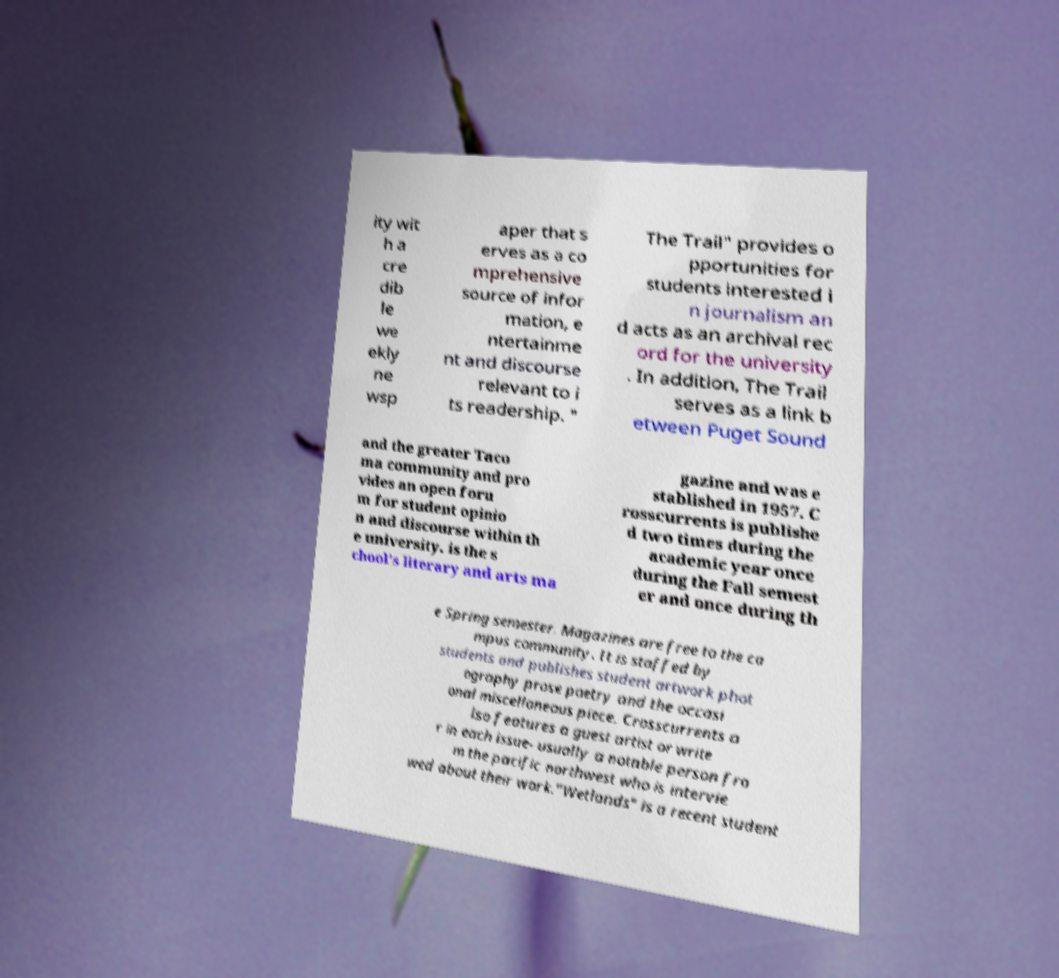Could you extract and type out the text from this image? ity wit h a cre dib le we ekly ne wsp aper that s erves as a co mprehensive source of infor mation, e ntertainme nt and discourse relevant to i ts readership. " The Trail" provides o pportunities for students interested i n journalism an d acts as an archival rec ord for the university . In addition, The Trail serves as a link b etween Puget Sound and the greater Taco ma community and pro vides an open foru m for student opinio n and discourse within th e university. is the s chool's literary and arts ma gazine and was e stablished in 1957. C rosscurrents is publishe d two times during the academic year once during the Fall semest er and once during th e Spring semester. Magazines are free to the ca mpus community. It is staffed by students and publishes student artwork phot ography prose poetry and the occasi onal miscellaneous piece. Crosscurrents a lso features a guest artist or write r in each issue- usually a notable person fro m the pacific northwest who is intervie wed about their work."Wetlands" is a recent student 